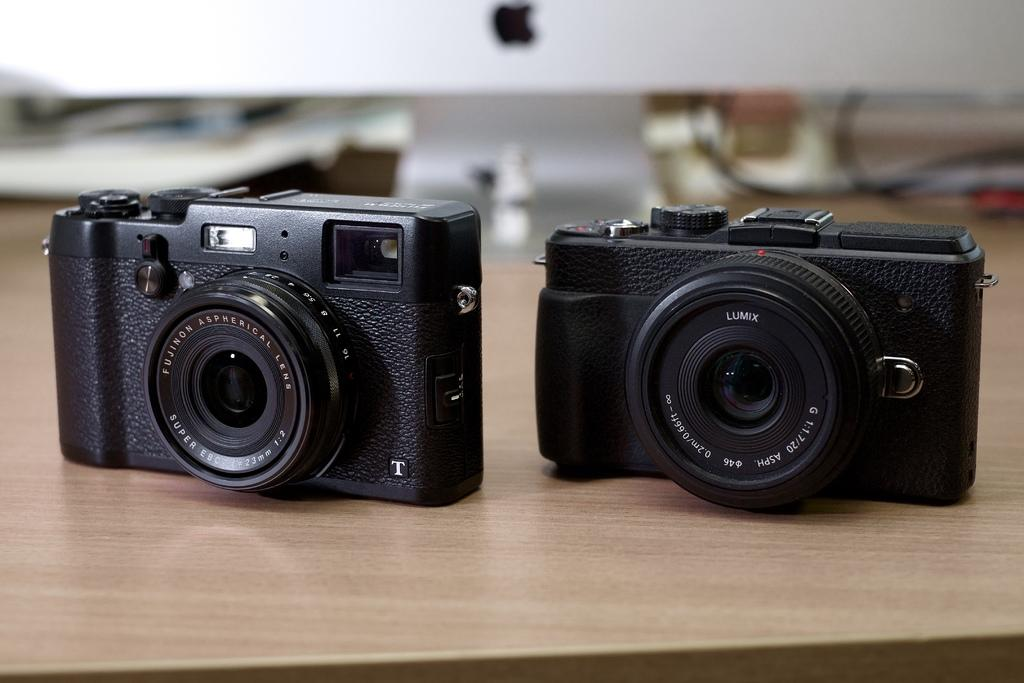What type of equipment is visible in the image? There are cameras in the image. What device is used for displaying visual information in the image? There is a monitor in the image. Where is the monitor located in the image? The monitor is on a table. What type of liquid is being poured into the camera in the image? There is no liquid being poured into the camera in the image; the cameras are not depicted as having any liquid interaction. 